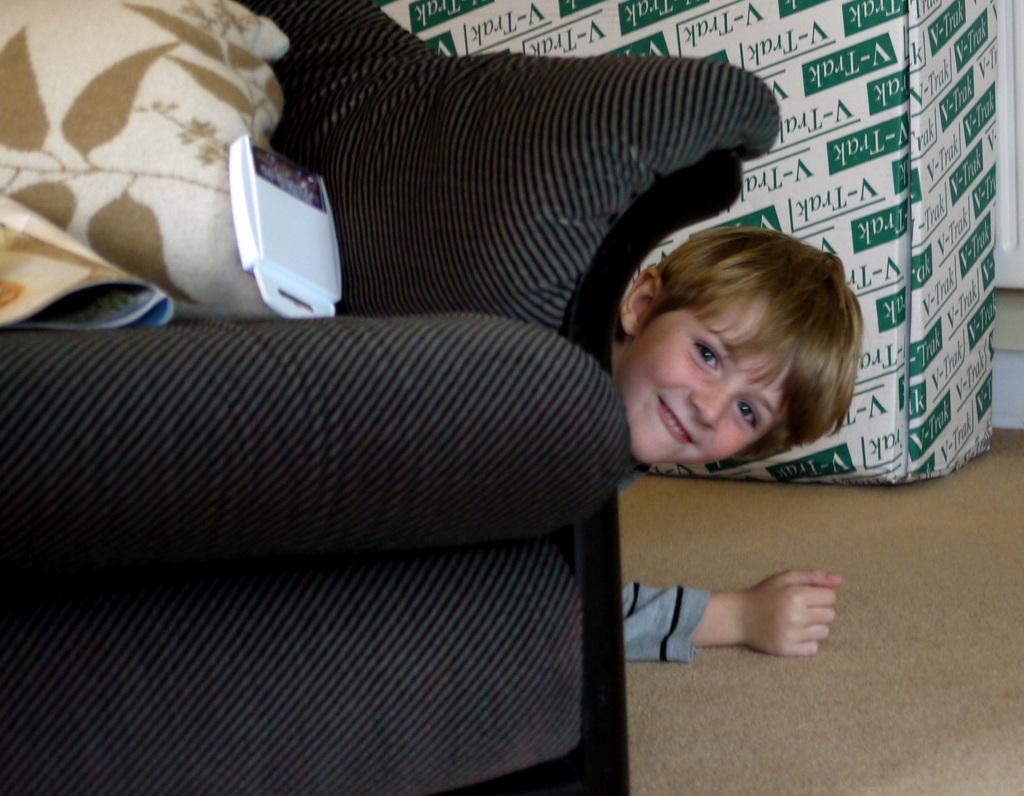What type of furniture is in the image? There is a sofa in the image. What is on the sofa? The sofa has pillows on it, and there is a device on the sofa. What is the boy in the image doing? The boy is on the ground in the image, and he is smiling. What object is near the boy? There is a cardboard box near the boy. How does the boy make the payment for the sofa in the image? There is no indication in the image that the boy is making a payment for the sofa, nor is there any information about the purchase of the sofa. 